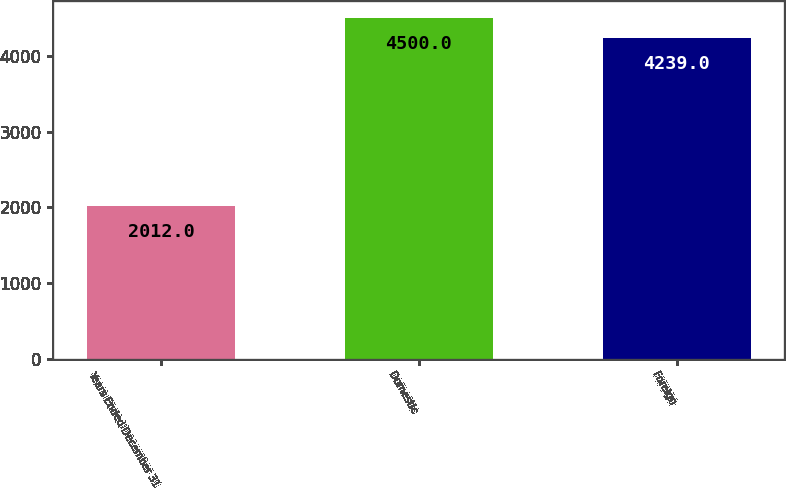Convert chart to OTSL. <chart><loc_0><loc_0><loc_500><loc_500><bar_chart><fcel>Years Ended December 31<fcel>Domestic<fcel>Foreign<nl><fcel>2012<fcel>4500<fcel>4239<nl></chart> 